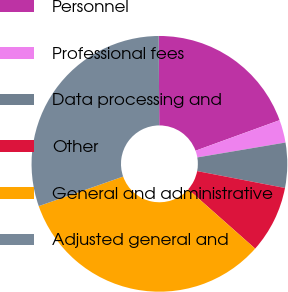Convert chart. <chart><loc_0><loc_0><loc_500><loc_500><pie_chart><fcel>Personnel<fcel>Professional fees<fcel>Data processing and<fcel>Other<fcel>General and administrative<fcel>Adjusted general and<nl><fcel>19.54%<fcel>2.88%<fcel>5.69%<fcel>8.51%<fcel>33.1%<fcel>30.28%<nl></chart> 